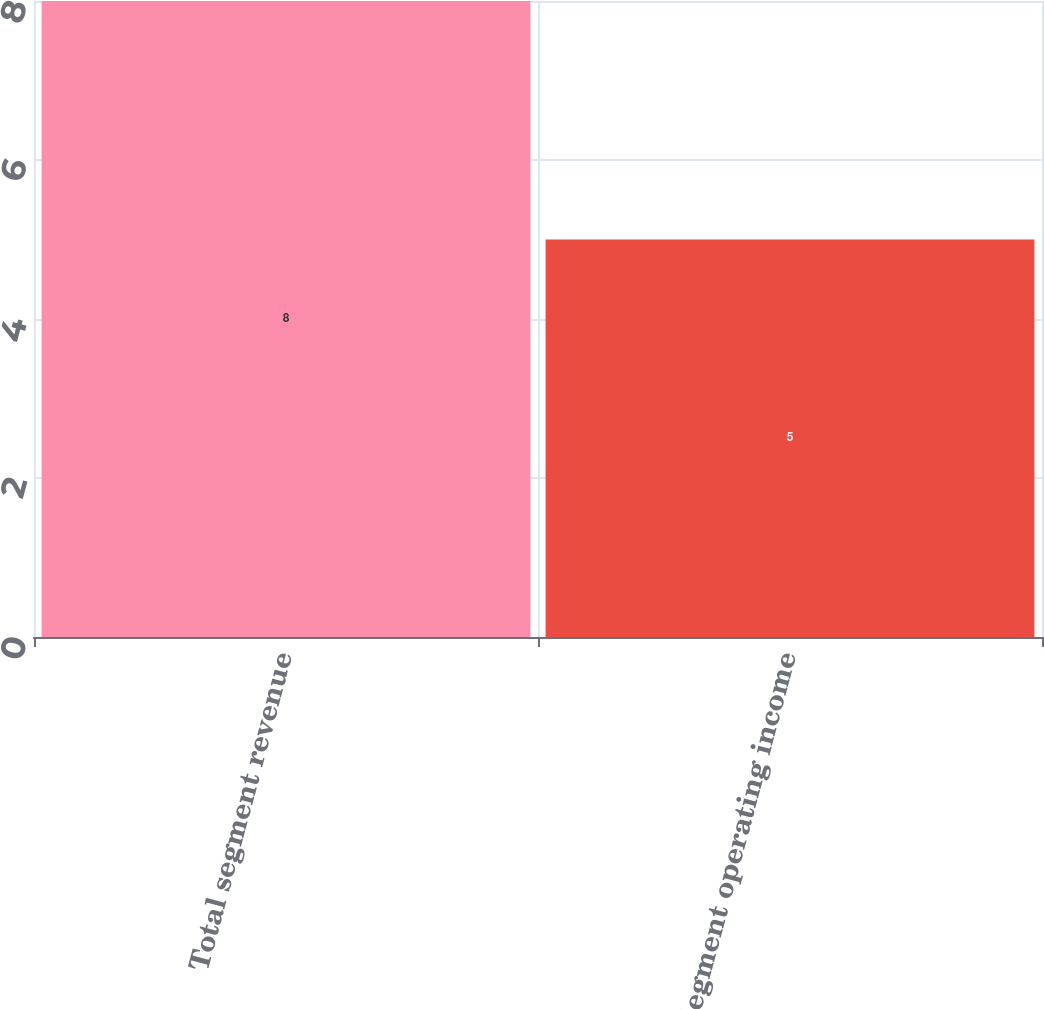Convert chart to OTSL. <chart><loc_0><loc_0><loc_500><loc_500><bar_chart><fcel>Total segment revenue<fcel>Segment operating income<nl><fcel>8<fcel>5<nl></chart> 